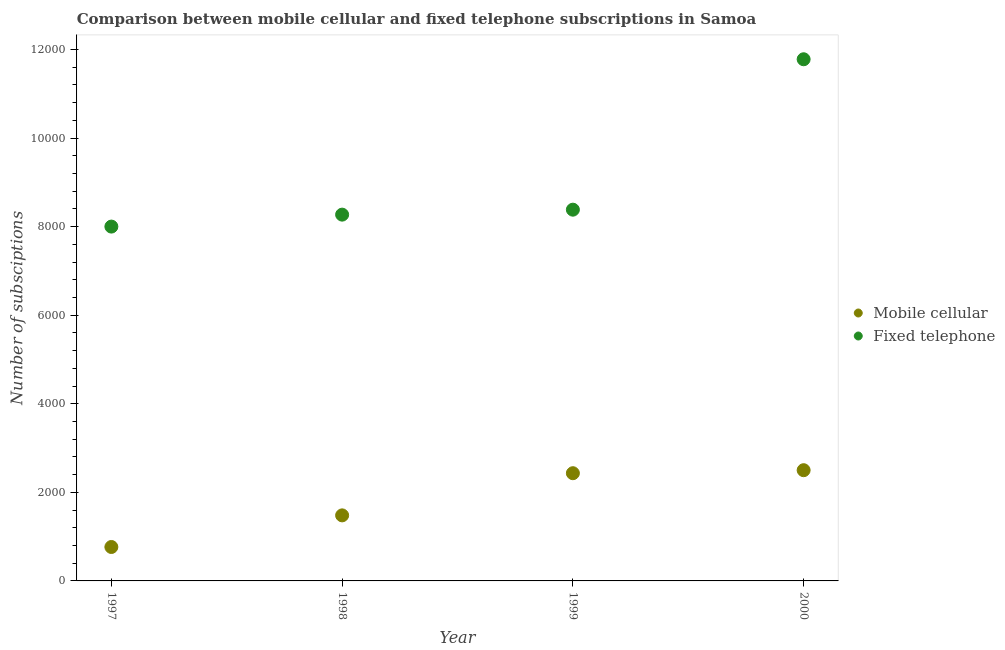How many different coloured dotlines are there?
Provide a succinct answer. 2. Is the number of dotlines equal to the number of legend labels?
Keep it short and to the point. Yes. What is the number of mobile cellular subscriptions in 1999?
Make the answer very short. 2432. Across all years, what is the maximum number of mobile cellular subscriptions?
Your answer should be very brief. 2500. Across all years, what is the minimum number of mobile cellular subscriptions?
Offer a very short reply. 766. In which year was the number of fixed telephone subscriptions maximum?
Your answer should be compact. 2000. In which year was the number of fixed telephone subscriptions minimum?
Ensure brevity in your answer.  1997. What is the total number of fixed telephone subscriptions in the graph?
Offer a terse response. 3.64e+04. What is the difference between the number of mobile cellular subscriptions in 1997 and that in 2000?
Offer a very short reply. -1734. What is the difference between the number of mobile cellular subscriptions in 1997 and the number of fixed telephone subscriptions in 2000?
Your answer should be compact. -1.10e+04. What is the average number of fixed telephone subscriptions per year?
Your answer should be very brief. 9107.5. In the year 1998, what is the difference between the number of fixed telephone subscriptions and number of mobile cellular subscriptions?
Give a very brief answer. 6790. In how many years, is the number of fixed telephone subscriptions greater than 11200?
Keep it short and to the point. 1. What is the ratio of the number of mobile cellular subscriptions in 1998 to that in 1999?
Offer a terse response. 0.61. Is the number of fixed telephone subscriptions in 1998 less than that in 1999?
Give a very brief answer. Yes. Is the difference between the number of fixed telephone subscriptions in 1998 and 2000 greater than the difference between the number of mobile cellular subscriptions in 1998 and 2000?
Your response must be concise. No. What is the difference between the highest and the second highest number of fixed telephone subscriptions?
Your answer should be compact. 3396. What is the difference between the highest and the lowest number of mobile cellular subscriptions?
Your answer should be compact. 1734. In how many years, is the number of fixed telephone subscriptions greater than the average number of fixed telephone subscriptions taken over all years?
Give a very brief answer. 1. Is the sum of the number of mobile cellular subscriptions in 1997 and 1999 greater than the maximum number of fixed telephone subscriptions across all years?
Keep it short and to the point. No. Is the number of mobile cellular subscriptions strictly greater than the number of fixed telephone subscriptions over the years?
Your response must be concise. No. Is the number of mobile cellular subscriptions strictly less than the number of fixed telephone subscriptions over the years?
Your answer should be very brief. Yes. How many years are there in the graph?
Provide a succinct answer. 4. Are the values on the major ticks of Y-axis written in scientific E-notation?
Your response must be concise. No. Where does the legend appear in the graph?
Your answer should be compact. Center right. What is the title of the graph?
Keep it short and to the point. Comparison between mobile cellular and fixed telephone subscriptions in Samoa. What is the label or title of the Y-axis?
Your answer should be compact. Number of subsciptions. What is the Number of subsciptions in Mobile cellular in 1997?
Offer a very short reply. 766. What is the Number of subsciptions in Fixed telephone in 1997?
Give a very brief answer. 8000. What is the Number of subsciptions of Mobile cellular in 1998?
Make the answer very short. 1480. What is the Number of subsciptions of Fixed telephone in 1998?
Your answer should be very brief. 8270. What is the Number of subsciptions in Mobile cellular in 1999?
Offer a terse response. 2432. What is the Number of subsciptions in Fixed telephone in 1999?
Keep it short and to the point. 8382. What is the Number of subsciptions of Mobile cellular in 2000?
Your answer should be very brief. 2500. What is the Number of subsciptions of Fixed telephone in 2000?
Offer a terse response. 1.18e+04. Across all years, what is the maximum Number of subsciptions of Mobile cellular?
Provide a short and direct response. 2500. Across all years, what is the maximum Number of subsciptions of Fixed telephone?
Provide a short and direct response. 1.18e+04. Across all years, what is the minimum Number of subsciptions in Mobile cellular?
Offer a very short reply. 766. Across all years, what is the minimum Number of subsciptions in Fixed telephone?
Ensure brevity in your answer.  8000. What is the total Number of subsciptions in Mobile cellular in the graph?
Ensure brevity in your answer.  7178. What is the total Number of subsciptions in Fixed telephone in the graph?
Keep it short and to the point. 3.64e+04. What is the difference between the Number of subsciptions of Mobile cellular in 1997 and that in 1998?
Offer a terse response. -714. What is the difference between the Number of subsciptions in Fixed telephone in 1997 and that in 1998?
Give a very brief answer. -270. What is the difference between the Number of subsciptions in Mobile cellular in 1997 and that in 1999?
Your response must be concise. -1666. What is the difference between the Number of subsciptions in Fixed telephone in 1997 and that in 1999?
Your answer should be compact. -382. What is the difference between the Number of subsciptions of Mobile cellular in 1997 and that in 2000?
Offer a very short reply. -1734. What is the difference between the Number of subsciptions of Fixed telephone in 1997 and that in 2000?
Provide a succinct answer. -3778. What is the difference between the Number of subsciptions of Mobile cellular in 1998 and that in 1999?
Provide a short and direct response. -952. What is the difference between the Number of subsciptions of Fixed telephone in 1998 and that in 1999?
Make the answer very short. -112. What is the difference between the Number of subsciptions of Mobile cellular in 1998 and that in 2000?
Make the answer very short. -1020. What is the difference between the Number of subsciptions in Fixed telephone in 1998 and that in 2000?
Your response must be concise. -3508. What is the difference between the Number of subsciptions of Mobile cellular in 1999 and that in 2000?
Provide a short and direct response. -68. What is the difference between the Number of subsciptions in Fixed telephone in 1999 and that in 2000?
Provide a succinct answer. -3396. What is the difference between the Number of subsciptions in Mobile cellular in 1997 and the Number of subsciptions in Fixed telephone in 1998?
Give a very brief answer. -7504. What is the difference between the Number of subsciptions of Mobile cellular in 1997 and the Number of subsciptions of Fixed telephone in 1999?
Make the answer very short. -7616. What is the difference between the Number of subsciptions of Mobile cellular in 1997 and the Number of subsciptions of Fixed telephone in 2000?
Make the answer very short. -1.10e+04. What is the difference between the Number of subsciptions in Mobile cellular in 1998 and the Number of subsciptions in Fixed telephone in 1999?
Your answer should be very brief. -6902. What is the difference between the Number of subsciptions in Mobile cellular in 1998 and the Number of subsciptions in Fixed telephone in 2000?
Your answer should be compact. -1.03e+04. What is the difference between the Number of subsciptions in Mobile cellular in 1999 and the Number of subsciptions in Fixed telephone in 2000?
Ensure brevity in your answer.  -9346. What is the average Number of subsciptions in Mobile cellular per year?
Provide a succinct answer. 1794.5. What is the average Number of subsciptions in Fixed telephone per year?
Offer a terse response. 9107.5. In the year 1997, what is the difference between the Number of subsciptions of Mobile cellular and Number of subsciptions of Fixed telephone?
Keep it short and to the point. -7234. In the year 1998, what is the difference between the Number of subsciptions in Mobile cellular and Number of subsciptions in Fixed telephone?
Keep it short and to the point. -6790. In the year 1999, what is the difference between the Number of subsciptions of Mobile cellular and Number of subsciptions of Fixed telephone?
Make the answer very short. -5950. In the year 2000, what is the difference between the Number of subsciptions of Mobile cellular and Number of subsciptions of Fixed telephone?
Provide a succinct answer. -9278. What is the ratio of the Number of subsciptions of Mobile cellular in 1997 to that in 1998?
Ensure brevity in your answer.  0.52. What is the ratio of the Number of subsciptions of Fixed telephone in 1997 to that in 1998?
Offer a very short reply. 0.97. What is the ratio of the Number of subsciptions in Mobile cellular in 1997 to that in 1999?
Give a very brief answer. 0.32. What is the ratio of the Number of subsciptions in Fixed telephone in 1997 to that in 1999?
Make the answer very short. 0.95. What is the ratio of the Number of subsciptions in Mobile cellular in 1997 to that in 2000?
Your answer should be compact. 0.31. What is the ratio of the Number of subsciptions of Fixed telephone in 1997 to that in 2000?
Offer a very short reply. 0.68. What is the ratio of the Number of subsciptions of Mobile cellular in 1998 to that in 1999?
Your answer should be very brief. 0.61. What is the ratio of the Number of subsciptions in Fixed telephone in 1998 to that in 1999?
Give a very brief answer. 0.99. What is the ratio of the Number of subsciptions in Mobile cellular in 1998 to that in 2000?
Make the answer very short. 0.59. What is the ratio of the Number of subsciptions in Fixed telephone in 1998 to that in 2000?
Provide a succinct answer. 0.7. What is the ratio of the Number of subsciptions of Mobile cellular in 1999 to that in 2000?
Ensure brevity in your answer.  0.97. What is the ratio of the Number of subsciptions of Fixed telephone in 1999 to that in 2000?
Give a very brief answer. 0.71. What is the difference between the highest and the second highest Number of subsciptions of Fixed telephone?
Your answer should be very brief. 3396. What is the difference between the highest and the lowest Number of subsciptions of Mobile cellular?
Give a very brief answer. 1734. What is the difference between the highest and the lowest Number of subsciptions in Fixed telephone?
Your answer should be compact. 3778. 